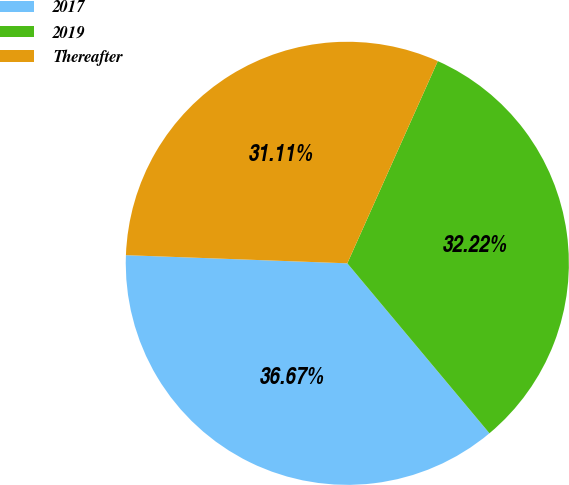Convert chart to OTSL. <chart><loc_0><loc_0><loc_500><loc_500><pie_chart><fcel>2017<fcel>2019<fcel>Thereafter<nl><fcel>36.67%<fcel>32.22%<fcel>31.11%<nl></chart> 